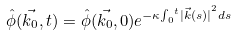Convert formula to latex. <formula><loc_0><loc_0><loc_500><loc_500>\hat { \phi } ( \vec { k _ { 0 } } , t ) = \hat { \phi } ( \vec { k _ { 0 } } , 0 ) e ^ { - \kappa { \int _ { 0 } } ^ { t } { | \vec { k } ( s ) | } ^ { 2 } d s }</formula> 